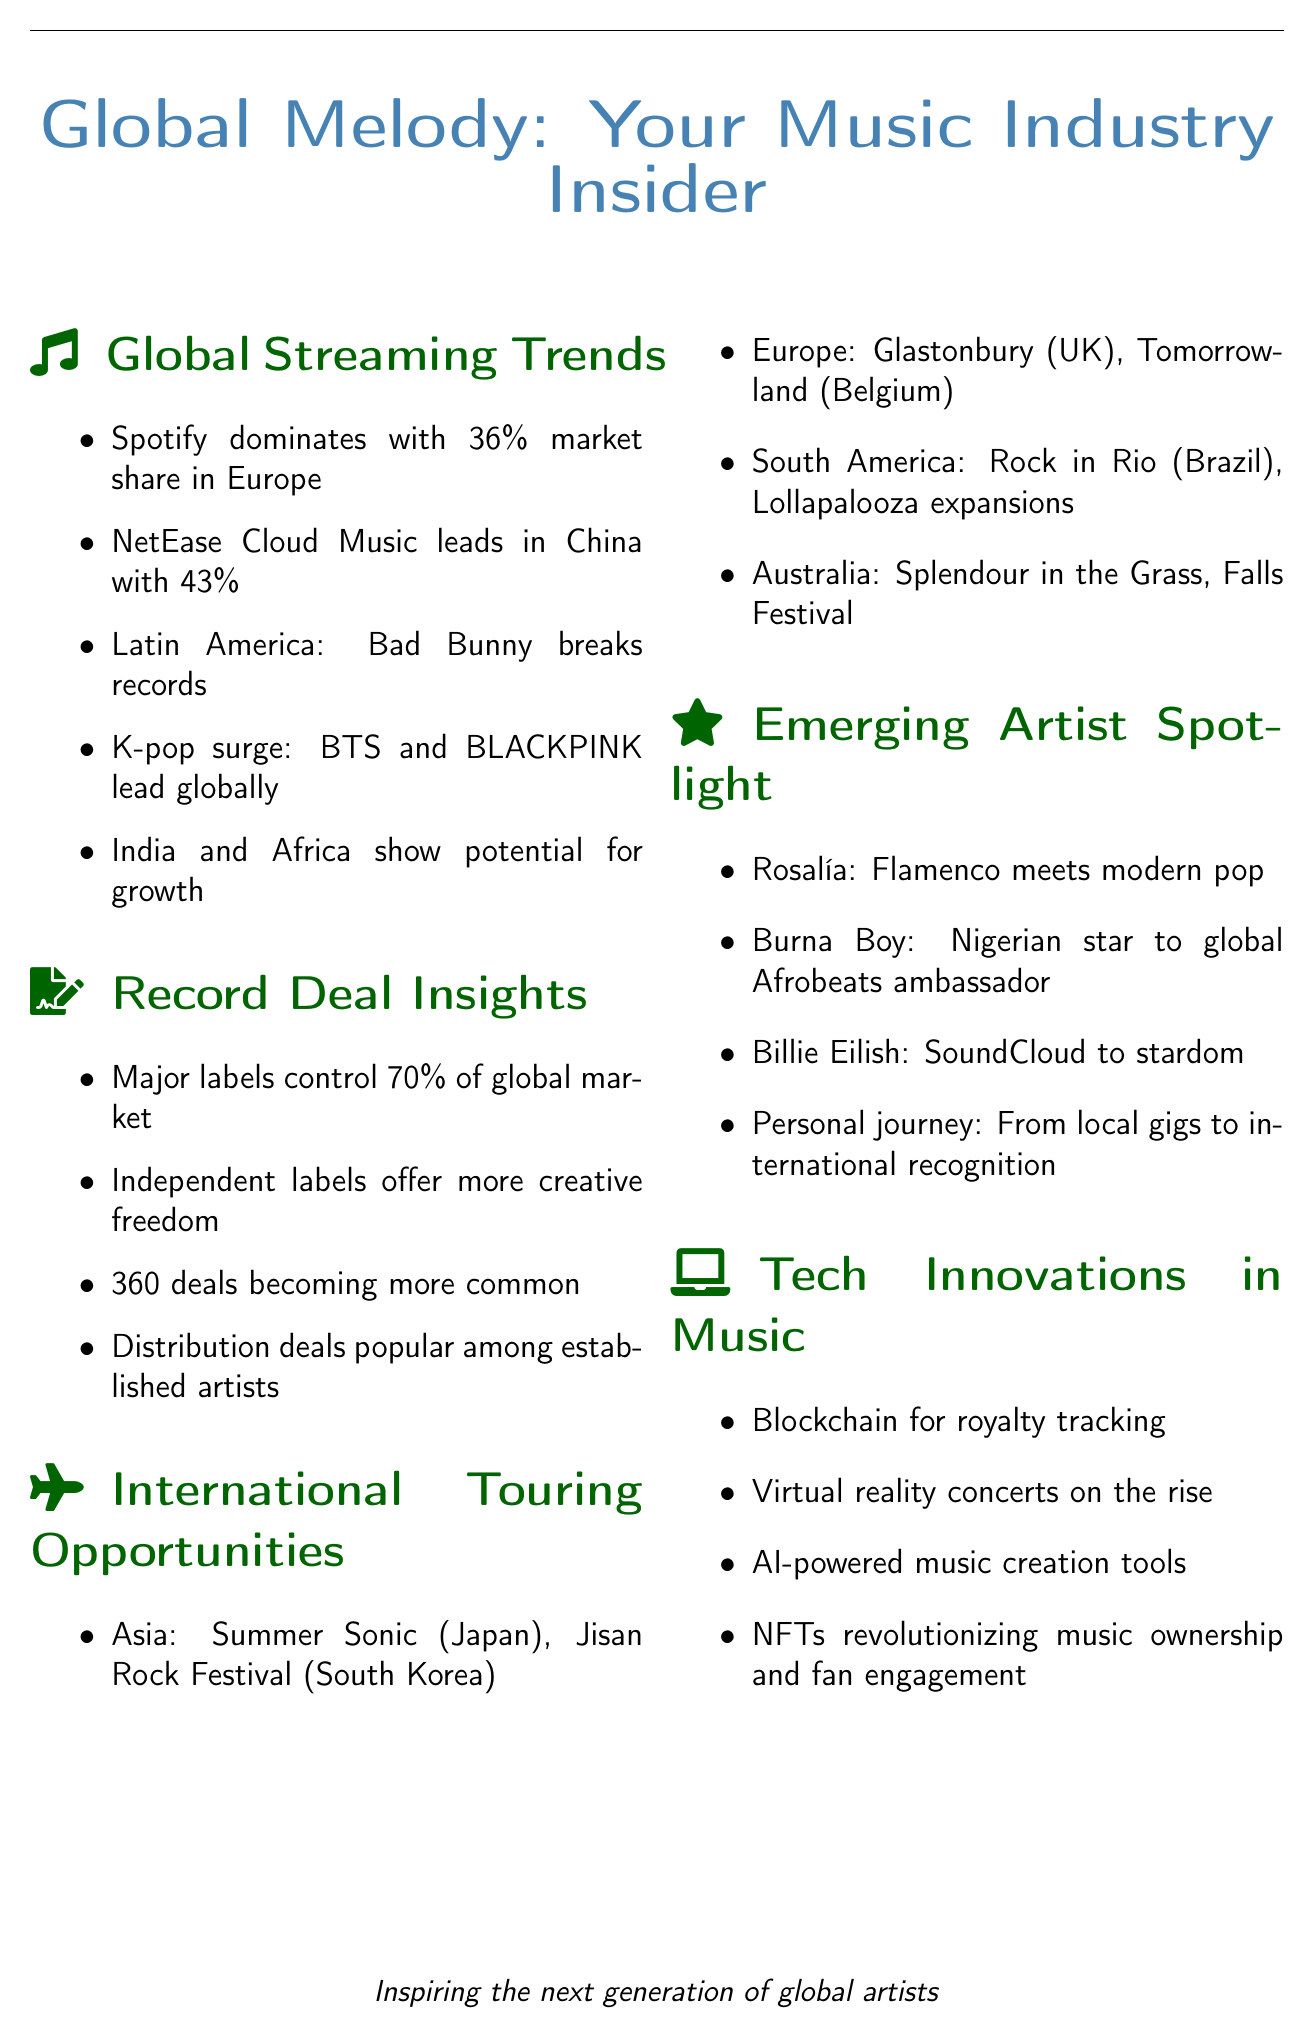What is Spotify's market share in Europe? Spotify holds a market share of 36% in Europe as mentioned in the streaming trends section.
Answer: 36% Which artist broke records in Latin America? Bad Bunny is noted for breaking records on multiple platforms in Latin America.
Answer: Bad Bunny What percentage of the global market do major labels control? Major labels such as Universal, Sony, and Warner control 70% of the global market according to the record deal insights.
Answer: 70% Name a popular festival in South America mentioned in the newsletter. Rock in Rio, highlighted as an expanding festival in South America, is one example from the touring opportunities section.
Answer: Rock in Rio What technology is being used for royalty tracking? Blockchain technology is mentioned for royalty tracking in the tech innovations section of the newsletter.
Answer: Blockchain Which emerging artist blends flamenco with modern pop? Rosalía is recognized for her success in combining flamenco with modern pop music.
Answer: Rosalía What trend is becoming more common among record deals? 360 deals are becoming more common as stated in the record deal insights.
Answer: 360 deals What festival is noted for attracting global acts in Asia? Summer Sonic in Japan is a festival that attracts global acts, as per the touring opportunities section.
Answer: Summer Sonic Which virtual reality concert platform is mentioned? Wave is one of the platforms referenced for virtual reality concerts in the tech innovations section.
Answer: Wave 